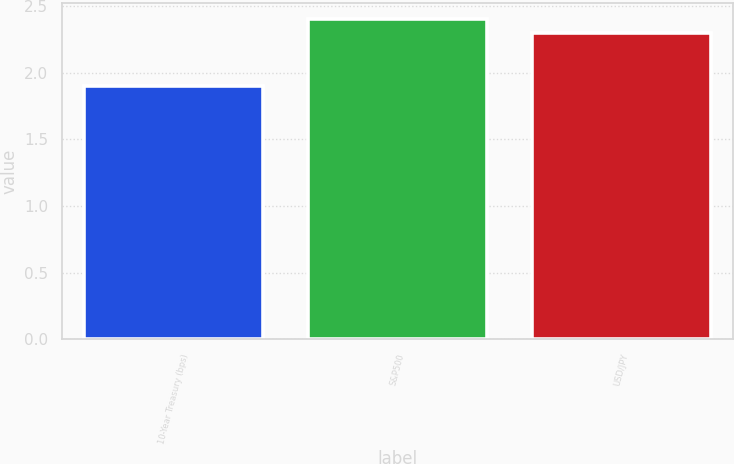Convert chart. <chart><loc_0><loc_0><loc_500><loc_500><bar_chart><fcel>10-Year Treasury (bps)<fcel>S&P500<fcel>USD/JPY<nl><fcel>1.9<fcel>2.4<fcel>2.3<nl></chart> 